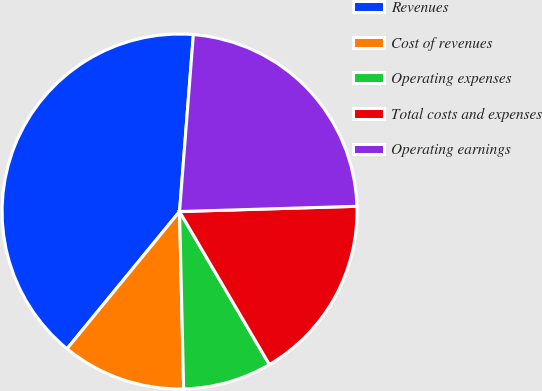<chart> <loc_0><loc_0><loc_500><loc_500><pie_chart><fcel>Revenues<fcel>Cost of revenues<fcel>Operating expenses<fcel>Total costs and expenses<fcel>Operating earnings<nl><fcel>40.31%<fcel>11.3%<fcel>8.08%<fcel>17.02%<fcel>23.29%<nl></chart> 